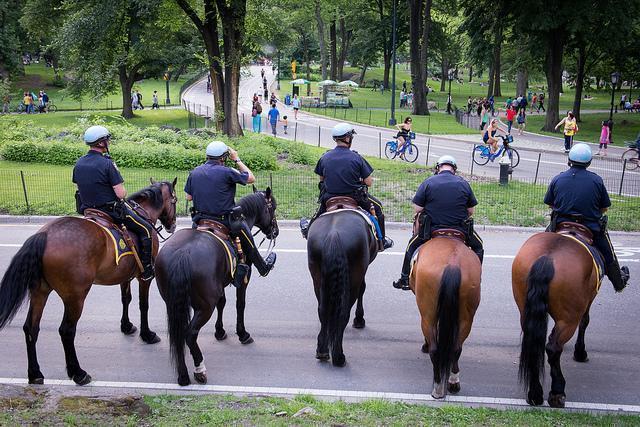What setting do these mounted persons stand in?
Choose the right answer and clarify with the format: 'Answer: answer
Rationale: rationale.'
Options: Park, riot, mall, grocery store. Answer: park.
Rationale: The area has the greenery and landscaping consistent with public parks. 